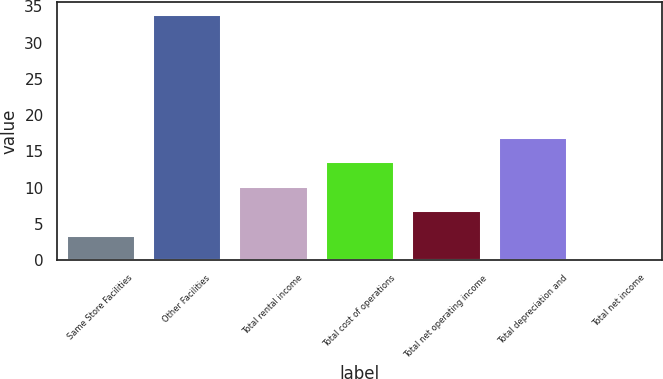<chart> <loc_0><loc_0><loc_500><loc_500><bar_chart><fcel>Same Store Facilities<fcel>Other Facilities<fcel>Total rental income<fcel>Total cost of operations<fcel>Total net operating income<fcel>Total depreciation and<fcel>Total net income<nl><fcel>3.48<fcel>33.9<fcel>10.24<fcel>13.62<fcel>6.86<fcel>17<fcel>0.1<nl></chart> 